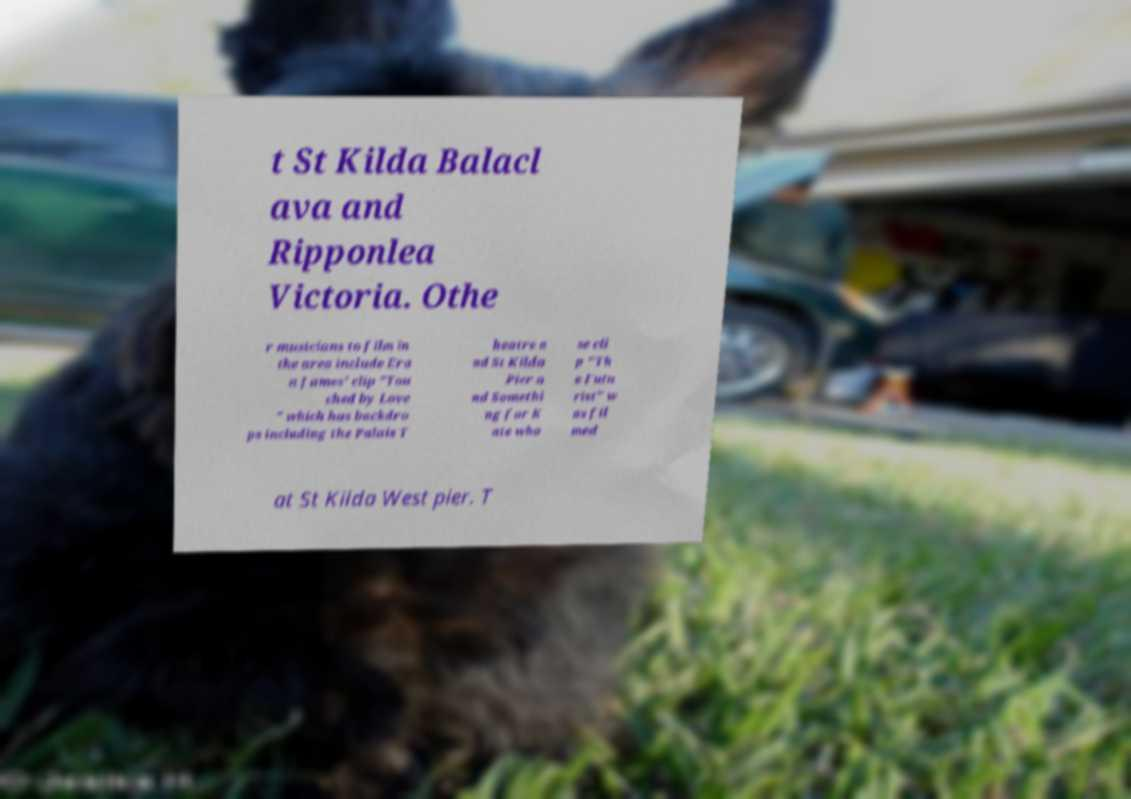Can you accurately transcribe the text from the provided image for me? t St Kilda Balacl ava and Ripponlea Victoria. Othe r musicians to film in the area include Era n James' clip "Tou ched by Love " which has backdro ps including the Palais T heatre a nd St Kilda Pier a nd Somethi ng for K ate who se cli p "Th e Futu rist" w as fil med at St Kilda West pier. T 